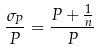Convert formula to latex. <formula><loc_0><loc_0><loc_500><loc_500>\frac { \sigma _ { P } } { P } = \frac { P + \frac { 1 } { n } } { P }</formula> 